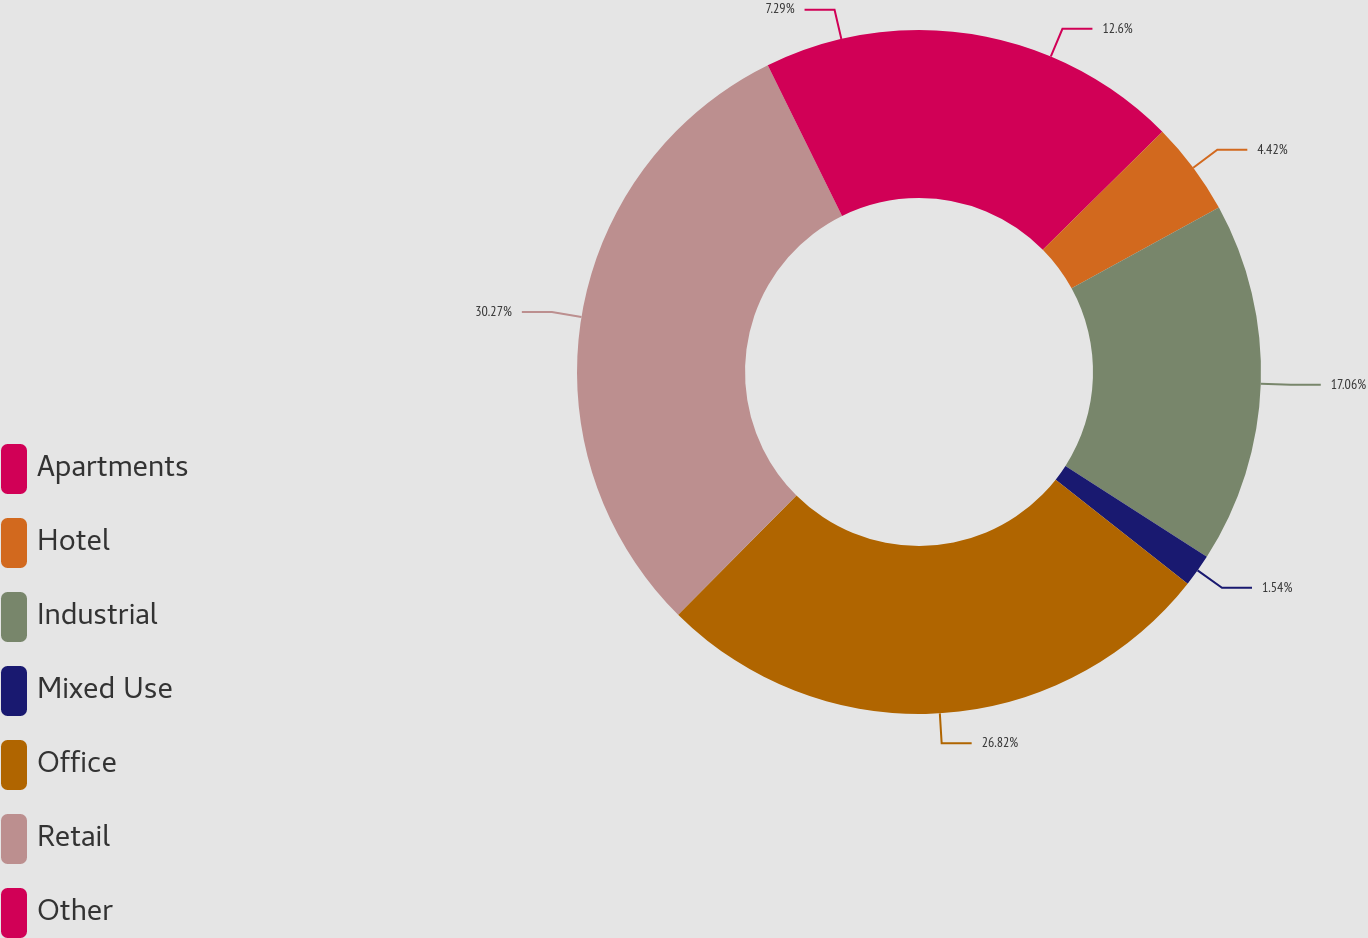Convert chart to OTSL. <chart><loc_0><loc_0><loc_500><loc_500><pie_chart><fcel>Apartments<fcel>Hotel<fcel>Industrial<fcel>Mixed Use<fcel>Office<fcel>Retail<fcel>Other<nl><fcel>12.6%<fcel>4.42%<fcel>17.06%<fcel>1.54%<fcel>26.82%<fcel>30.27%<fcel>7.29%<nl></chart> 